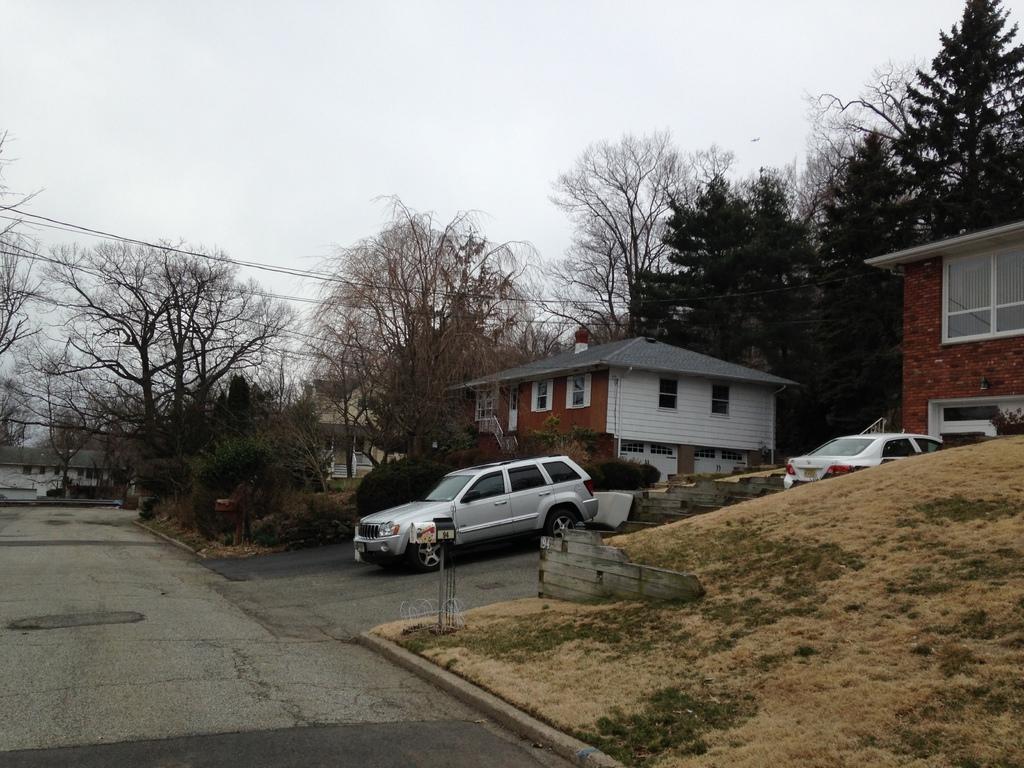In one or two sentences, can you explain what this image depicts? In this image we can see some buildings and there are some trees and plants. We can see some vehicles on the road and at the top we can see the sky. 